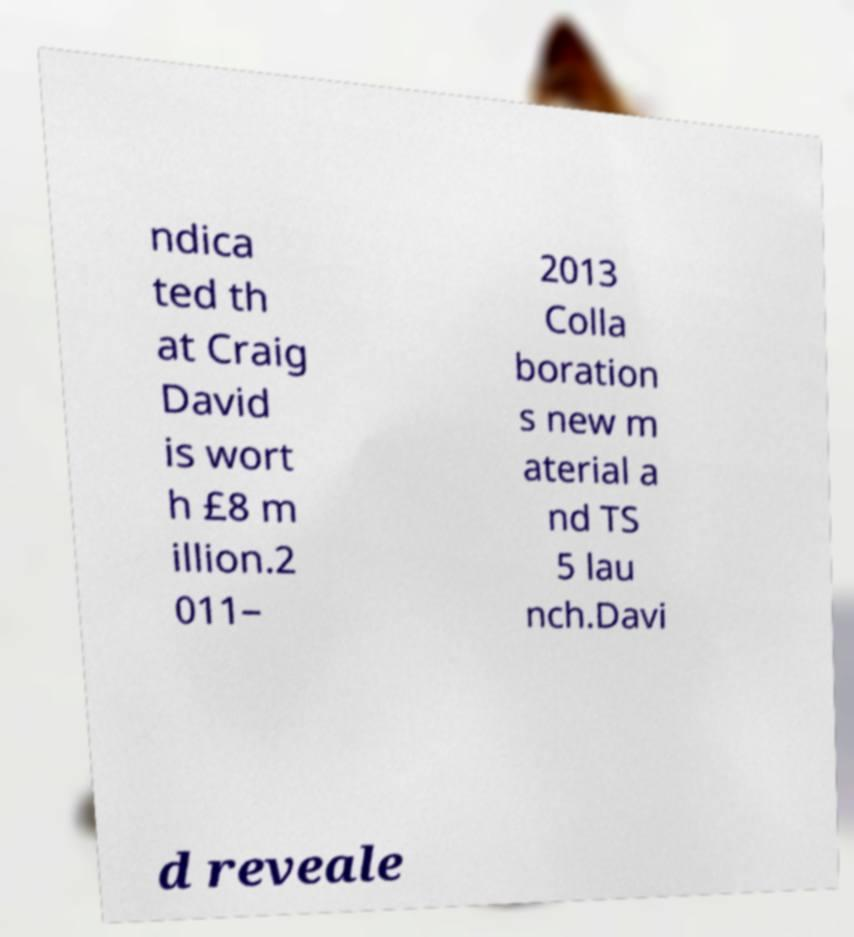What messages or text are displayed in this image? I need them in a readable, typed format. ndica ted th at Craig David is wort h £8 m illion.2 011– 2013 Colla boration s new m aterial a nd TS 5 lau nch.Davi d reveale 